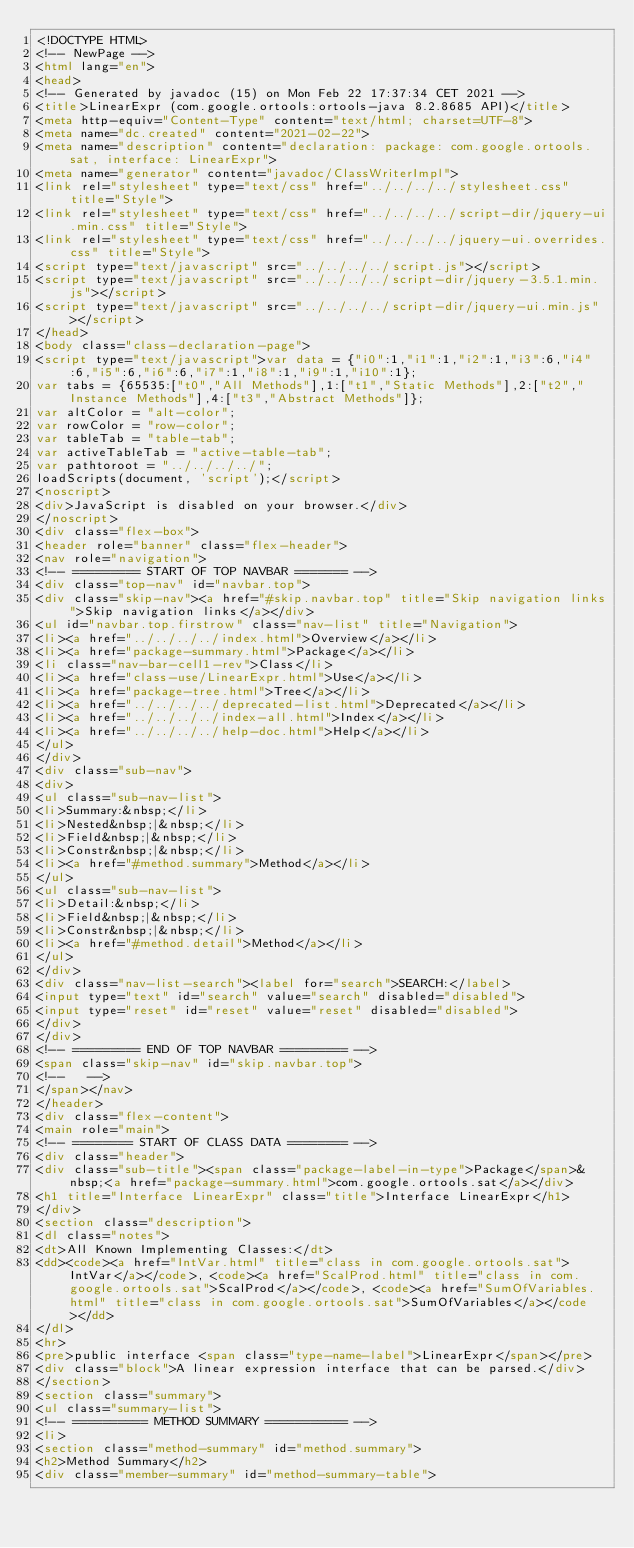<code> <loc_0><loc_0><loc_500><loc_500><_HTML_><!DOCTYPE HTML>
<!-- NewPage -->
<html lang="en">
<head>
<!-- Generated by javadoc (15) on Mon Feb 22 17:37:34 CET 2021 -->
<title>LinearExpr (com.google.ortools:ortools-java 8.2.8685 API)</title>
<meta http-equiv="Content-Type" content="text/html; charset=UTF-8">
<meta name="dc.created" content="2021-02-22">
<meta name="description" content="declaration: package: com.google.ortools.sat, interface: LinearExpr">
<meta name="generator" content="javadoc/ClassWriterImpl">
<link rel="stylesheet" type="text/css" href="../../../../stylesheet.css" title="Style">
<link rel="stylesheet" type="text/css" href="../../../../script-dir/jquery-ui.min.css" title="Style">
<link rel="stylesheet" type="text/css" href="../../../../jquery-ui.overrides.css" title="Style">
<script type="text/javascript" src="../../../../script.js"></script>
<script type="text/javascript" src="../../../../script-dir/jquery-3.5.1.min.js"></script>
<script type="text/javascript" src="../../../../script-dir/jquery-ui.min.js"></script>
</head>
<body class="class-declaration-page">
<script type="text/javascript">var data = {"i0":1,"i1":1,"i2":1,"i3":6,"i4":6,"i5":6,"i6":6,"i7":1,"i8":1,"i9":1,"i10":1};
var tabs = {65535:["t0","All Methods"],1:["t1","Static Methods"],2:["t2","Instance Methods"],4:["t3","Abstract Methods"]};
var altColor = "alt-color";
var rowColor = "row-color";
var tableTab = "table-tab";
var activeTableTab = "active-table-tab";
var pathtoroot = "../../../../";
loadScripts(document, 'script');</script>
<noscript>
<div>JavaScript is disabled on your browser.</div>
</noscript>
<div class="flex-box">
<header role="banner" class="flex-header">
<nav role="navigation">
<!-- ========= START OF TOP NAVBAR ======= -->
<div class="top-nav" id="navbar.top">
<div class="skip-nav"><a href="#skip.navbar.top" title="Skip navigation links">Skip navigation links</a></div>
<ul id="navbar.top.firstrow" class="nav-list" title="Navigation">
<li><a href="../../../../index.html">Overview</a></li>
<li><a href="package-summary.html">Package</a></li>
<li class="nav-bar-cell1-rev">Class</li>
<li><a href="class-use/LinearExpr.html">Use</a></li>
<li><a href="package-tree.html">Tree</a></li>
<li><a href="../../../../deprecated-list.html">Deprecated</a></li>
<li><a href="../../../../index-all.html">Index</a></li>
<li><a href="../../../../help-doc.html">Help</a></li>
</ul>
</div>
<div class="sub-nav">
<div>
<ul class="sub-nav-list">
<li>Summary:&nbsp;</li>
<li>Nested&nbsp;|&nbsp;</li>
<li>Field&nbsp;|&nbsp;</li>
<li>Constr&nbsp;|&nbsp;</li>
<li><a href="#method.summary">Method</a></li>
</ul>
<ul class="sub-nav-list">
<li>Detail:&nbsp;</li>
<li>Field&nbsp;|&nbsp;</li>
<li>Constr&nbsp;|&nbsp;</li>
<li><a href="#method.detail">Method</a></li>
</ul>
</div>
<div class="nav-list-search"><label for="search">SEARCH:</label>
<input type="text" id="search" value="search" disabled="disabled">
<input type="reset" id="reset" value="reset" disabled="disabled">
</div>
</div>
<!-- ========= END OF TOP NAVBAR ========= -->
<span class="skip-nav" id="skip.navbar.top">
<!--   -->
</span></nav>
</header>
<div class="flex-content">
<main role="main">
<!-- ======== START OF CLASS DATA ======== -->
<div class="header">
<div class="sub-title"><span class="package-label-in-type">Package</span>&nbsp;<a href="package-summary.html">com.google.ortools.sat</a></div>
<h1 title="Interface LinearExpr" class="title">Interface LinearExpr</h1>
</div>
<section class="description">
<dl class="notes">
<dt>All Known Implementing Classes:</dt>
<dd><code><a href="IntVar.html" title="class in com.google.ortools.sat">IntVar</a></code>, <code><a href="ScalProd.html" title="class in com.google.ortools.sat">ScalProd</a></code>, <code><a href="SumOfVariables.html" title="class in com.google.ortools.sat">SumOfVariables</a></code></dd>
</dl>
<hr>
<pre>public interface <span class="type-name-label">LinearExpr</span></pre>
<div class="block">A linear expression interface that can be parsed.</div>
</section>
<section class="summary">
<ul class="summary-list">
<!-- ========== METHOD SUMMARY =========== -->
<li>
<section class="method-summary" id="method.summary">
<h2>Method Summary</h2>
<div class="member-summary" id="method-summary-table"></code> 